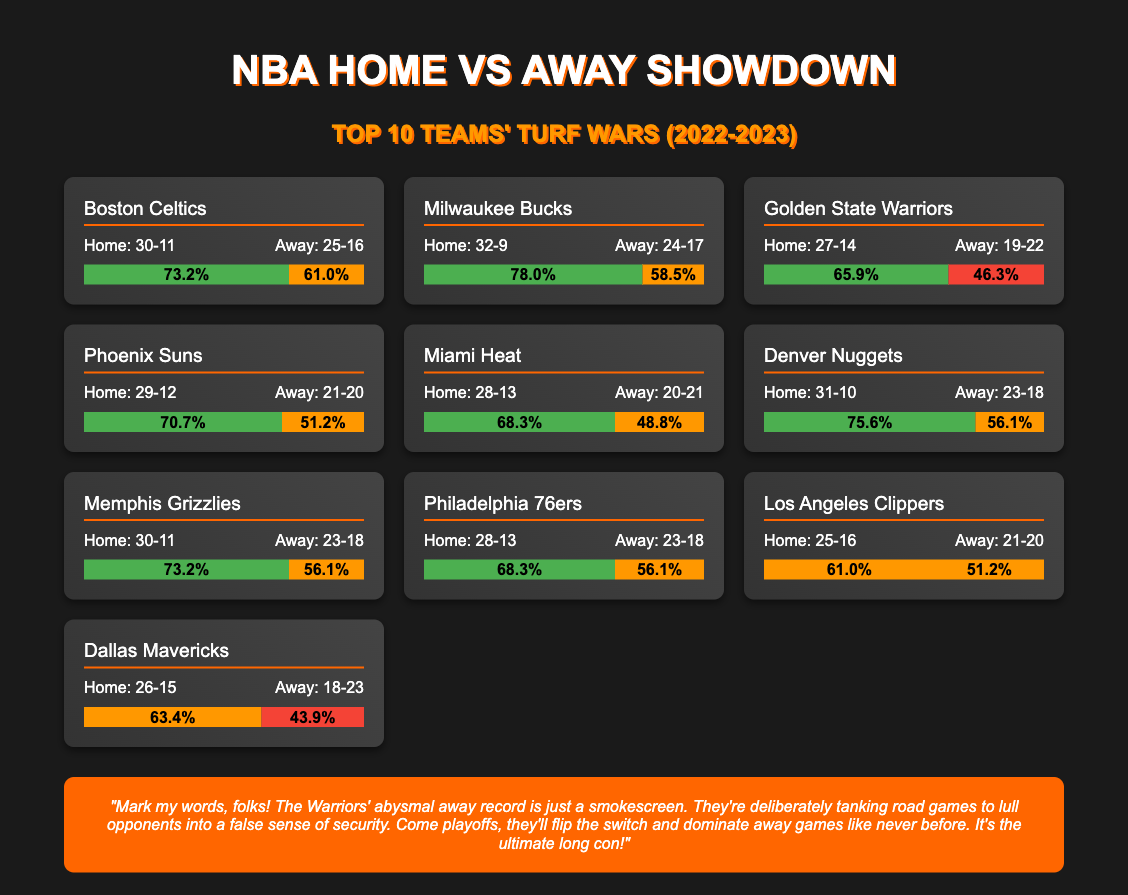What is the home record of the Boston Celtics? The home record is found in the document under the Boston Celtics section, which states "Home: 30-11."
Answer: 30-11 What is the away win percentage for the Milwaukee Bucks? The away win percentage is indicated in the Milwaukee Bucks section, showing "58.5%."
Answer: 58.5% Which team has the highest home win percentage? By comparing the home percentages listed, Milwaukee Bucks show the highest at "78.0%."
Answer: 78.0% What is the away record for the Golden State Warriors? The away record is detailed in the section for the Golden State Warriors, listed as "Away: 19-22."
Answer: 19-22 Which team has the lowest away win percentage? Assessing all teams' away percentages, the Golden State Warriors have the lowest at "46.3%."
Answer: 46.3% What do the color codes represent in the performance chart? The color codes in the chart indicate win percentages, with green for home wins, orange for moderate away wins, and red for losses.
Answer: Win percentages What is the home and away record for the Miami Heat? The document lists the Miami Heat's home and away records in the respective section: "Home: 28-13" and "Away: 20-21."
Answer: Home: 28-13, Away: 20-21 How many teams have a home winning percentage above 70%? Counting from the document, there are five teams with home winning percentages above 70%.
Answer: Five What is the hot take presented at the end of the infographic? The document concludes with a hot take claiming that the Golden State Warriors are "deliberately tanking road games."
Answer: Deliberately tanking road games 